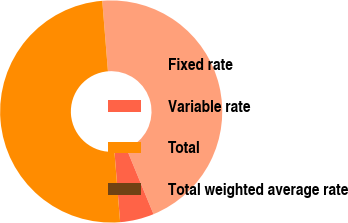<chart> <loc_0><loc_0><loc_500><loc_500><pie_chart><fcel>Fixed rate<fcel>Variable rate<fcel>Total<fcel>Total weighted average rate<nl><fcel>45.06%<fcel>4.94%<fcel>50.0%<fcel>0.0%<nl></chart> 